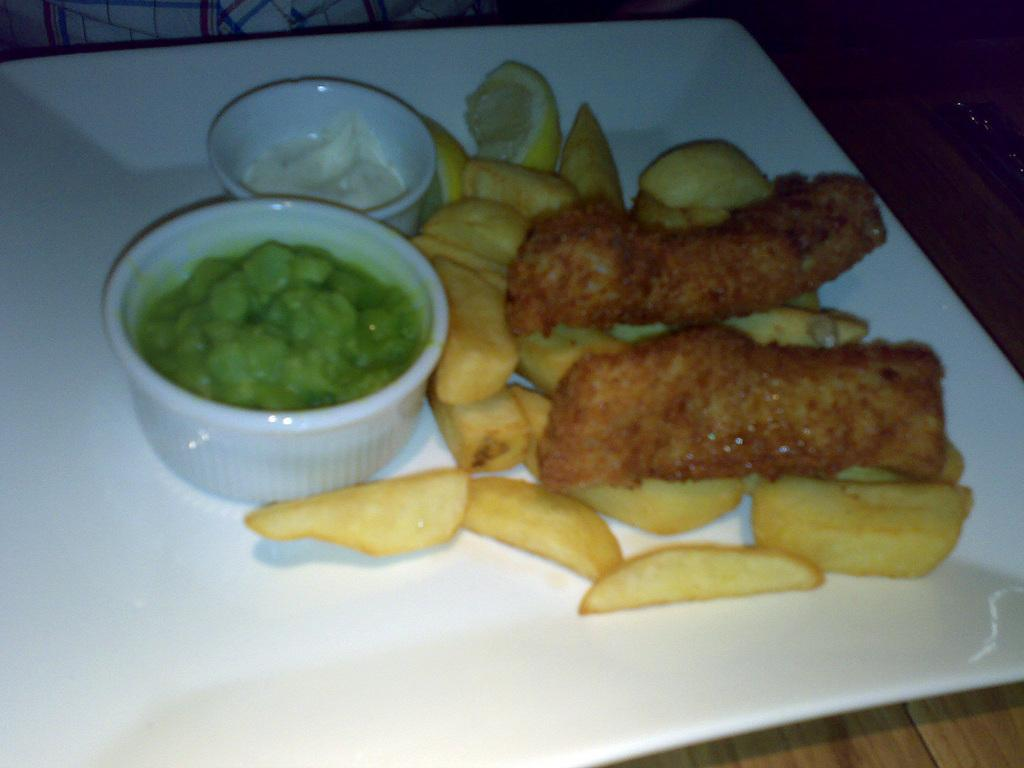What is on the plate that is visible in the image? There is food placed on a plate in the image. What type of table is the food placed on? There is a wooden table in the image. Are there any other containers for food in the image? Yes, there are two bowls on the wooden table. Can you describe the setting in the background of the image? There is a man sitting in the background of the image. How many pizzas are being prepared by the beginner chef in the image? There is no information about pizzas or a beginner chef in the image. 